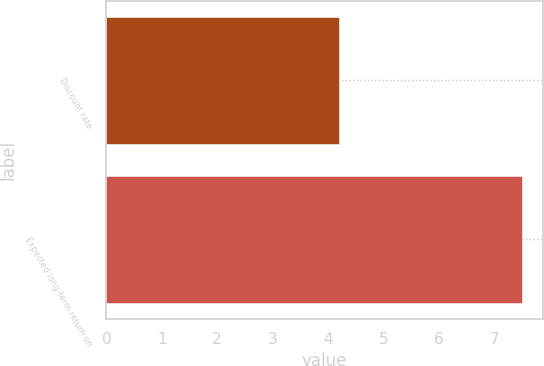Convert chart to OTSL. <chart><loc_0><loc_0><loc_500><loc_500><bar_chart><fcel>Discount rate<fcel>Expected long-term return on<nl><fcel>4.2<fcel>7.5<nl></chart> 